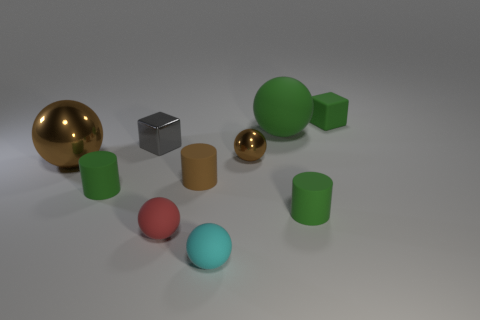Subtract all cyan cubes. Subtract all blue cylinders. How many cubes are left? 2 Subtract all green cubes. How many blue spheres are left? 0 Add 6 small objects. How many small browns exist? 0 Subtract all small red spheres. Subtract all brown rubber cylinders. How many objects are left? 8 Add 2 small cubes. How many small cubes are left? 4 Add 5 tiny purple balls. How many tiny purple balls exist? 5 Subtract all green cylinders. How many cylinders are left? 1 Subtract all green cylinders. How many cylinders are left? 1 Subtract 1 brown cylinders. How many objects are left? 9 Subtract all green cylinders. How many were subtracted if there are1green cylinders left? 1 